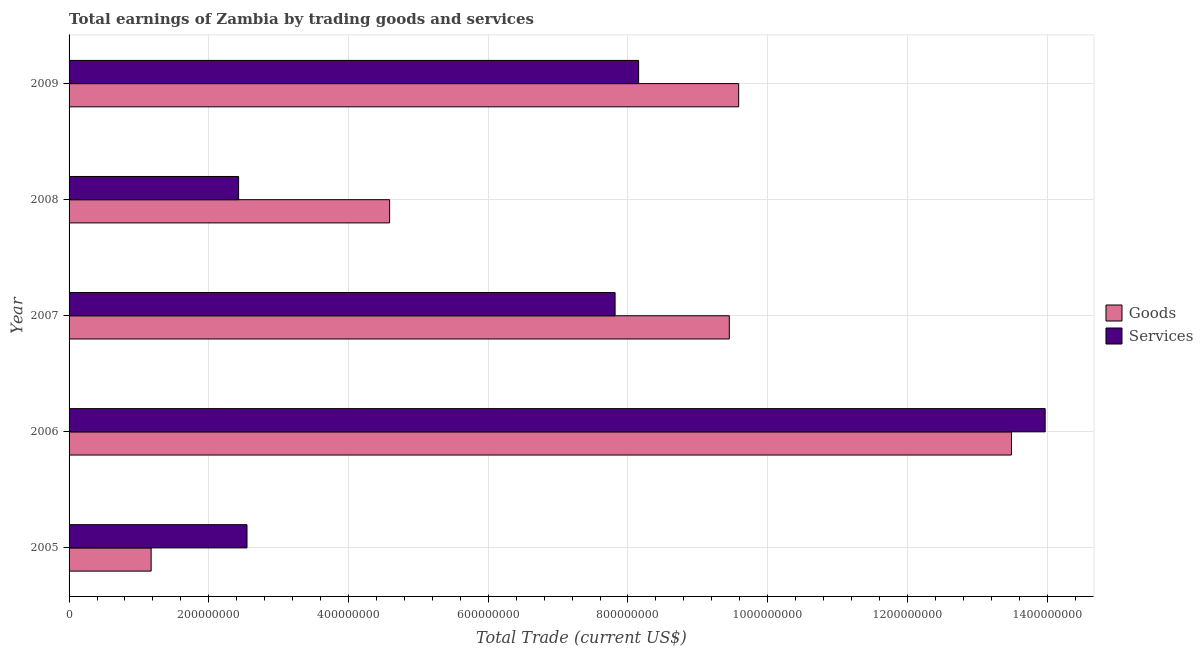How many groups of bars are there?
Your response must be concise. 5. How many bars are there on the 2nd tick from the top?
Offer a terse response. 2. How many bars are there on the 3rd tick from the bottom?
Your response must be concise. 2. What is the label of the 3rd group of bars from the top?
Keep it short and to the point. 2007. What is the amount earned by trading services in 2007?
Offer a very short reply. 7.82e+08. Across all years, what is the maximum amount earned by trading services?
Make the answer very short. 1.40e+09. Across all years, what is the minimum amount earned by trading services?
Ensure brevity in your answer.  2.43e+08. What is the total amount earned by trading services in the graph?
Keep it short and to the point. 3.49e+09. What is the difference between the amount earned by trading goods in 2007 and that in 2009?
Give a very brief answer. -1.34e+07. What is the difference between the amount earned by trading goods in 2009 and the amount earned by trading services in 2008?
Offer a very short reply. 7.16e+08. What is the average amount earned by trading services per year?
Your answer should be compact. 6.98e+08. In the year 2009, what is the difference between the amount earned by trading services and amount earned by trading goods?
Keep it short and to the point. -1.43e+08. In how many years, is the amount earned by trading goods greater than 1040000000 US$?
Ensure brevity in your answer.  1. What is the ratio of the amount earned by trading goods in 2005 to that in 2008?
Your answer should be compact. 0.26. Is the difference between the amount earned by trading services in 2006 and 2007 greater than the difference between the amount earned by trading goods in 2006 and 2007?
Make the answer very short. Yes. What is the difference between the highest and the second highest amount earned by trading services?
Your answer should be very brief. 5.82e+08. What is the difference between the highest and the lowest amount earned by trading services?
Keep it short and to the point. 1.15e+09. Is the sum of the amount earned by trading services in 2005 and 2007 greater than the maximum amount earned by trading goods across all years?
Your response must be concise. No. What does the 1st bar from the top in 2005 represents?
Keep it short and to the point. Services. What does the 1st bar from the bottom in 2009 represents?
Offer a very short reply. Goods. How many bars are there?
Keep it short and to the point. 10. Are all the bars in the graph horizontal?
Ensure brevity in your answer.  Yes. Are the values on the major ticks of X-axis written in scientific E-notation?
Offer a terse response. No. How many legend labels are there?
Ensure brevity in your answer.  2. How are the legend labels stacked?
Make the answer very short. Vertical. What is the title of the graph?
Ensure brevity in your answer.  Total earnings of Zambia by trading goods and services. Does "By country of asylum" appear as one of the legend labels in the graph?
Your response must be concise. No. What is the label or title of the X-axis?
Give a very brief answer. Total Trade (current US$). What is the Total Trade (current US$) in Goods in 2005?
Give a very brief answer. 1.17e+08. What is the Total Trade (current US$) in Services in 2005?
Your answer should be compact. 2.55e+08. What is the Total Trade (current US$) in Goods in 2006?
Offer a very short reply. 1.35e+09. What is the Total Trade (current US$) of Services in 2006?
Your response must be concise. 1.40e+09. What is the Total Trade (current US$) in Goods in 2007?
Your answer should be very brief. 9.45e+08. What is the Total Trade (current US$) in Services in 2007?
Your response must be concise. 7.82e+08. What is the Total Trade (current US$) of Goods in 2008?
Give a very brief answer. 4.59e+08. What is the Total Trade (current US$) of Services in 2008?
Your response must be concise. 2.43e+08. What is the Total Trade (current US$) in Goods in 2009?
Offer a very short reply. 9.59e+08. What is the Total Trade (current US$) of Services in 2009?
Ensure brevity in your answer.  8.15e+08. Across all years, what is the maximum Total Trade (current US$) of Goods?
Provide a succinct answer. 1.35e+09. Across all years, what is the maximum Total Trade (current US$) of Services?
Make the answer very short. 1.40e+09. Across all years, what is the minimum Total Trade (current US$) in Goods?
Keep it short and to the point. 1.17e+08. Across all years, what is the minimum Total Trade (current US$) in Services?
Offer a terse response. 2.43e+08. What is the total Total Trade (current US$) in Goods in the graph?
Your answer should be compact. 3.83e+09. What is the total Total Trade (current US$) of Services in the graph?
Your answer should be very brief. 3.49e+09. What is the difference between the Total Trade (current US$) of Goods in 2005 and that in 2006?
Give a very brief answer. -1.23e+09. What is the difference between the Total Trade (current US$) of Services in 2005 and that in 2006?
Offer a very short reply. -1.14e+09. What is the difference between the Total Trade (current US$) in Goods in 2005 and that in 2007?
Keep it short and to the point. -8.28e+08. What is the difference between the Total Trade (current US$) in Services in 2005 and that in 2007?
Offer a terse response. -5.27e+08. What is the difference between the Total Trade (current US$) in Goods in 2005 and that in 2008?
Provide a succinct answer. -3.41e+08. What is the difference between the Total Trade (current US$) of Services in 2005 and that in 2008?
Keep it short and to the point. 1.20e+07. What is the difference between the Total Trade (current US$) in Goods in 2005 and that in 2009?
Provide a succinct answer. -8.41e+08. What is the difference between the Total Trade (current US$) in Services in 2005 and that in 2009?
Your answer should be compact. -5.61e+08. What is the difference between the Total Trade (current US$) in Goods in 2006 and that in 2007?
Make the answer very short. 4.04e+08. What is the difference between the Total Trade (current US$) of Services in 2006 and that in 2007?
Provide a succinct answer. 6.16e+08. What is the difference between the Total Trade (current US$) in Goods in 2006 and that in 2008?
Ensure brevity in your answer.  8.90e+08. What is the difference between the Total Trade (current US$) of Services in 2006 and that in 2008?
Your answer should be very brief. 1.15e+09. What is the difference between the Total Trade (current US$) of Goods in 2006 and that in 2009?
Keep it short and to the point. 3.90e+08. What is the difference between the Total Trade (current US$) in Services in 2006 and that in 2009?
Ensure brevity in your answer.  5.82e+08. What is the difference between the Total Trade (current US$) of Goods in 2007 and that in 2008?
Provide a short and direct response. 4.86e+08. What is the difference between the Total Trade (current US$) of Services in 2007 and that in 2008?
Provide a short and direct response. 5.39e+08. What is the difference between the Total Trade (current US$) of Goods in 2007 and that in 2009?
Your response must be concise. -1.34e+07. What is the difference between the Total Trade (current US$) of Services in 2007 and that in 2009?
Your answer should be very brief. -3.37e+07. What is the difference between the Total Trade (current US$) in Goods in 2008 and that in 2009?
Ensure brevity in your answer.  -5.00e+08. What is the difference between the Total Trade (current US$) in Services in 2008 and that in 2009?
Keep it short and to the point. -5.73e+08. What is the difference between the Total Trade (current US$) in Goods in 2005 and the Total Trade (current US$) in Services in 2006?
Provide a succinct answer. -1.28e+09. What is the difference between the Total Trade (current US$) of Goods in 2005 and the Total Trade (current US$) of Services in 2007?
Keep it short and to the point. -6.64e+08. What is the difference between the Total Trade (current US$) in Goods in 2005 and the Total Trade (current US$) in Services in 2008?
Offer a very short reply. -1.25e+08. What is the difference between the Total Trade (current US$) in Goods in 2005 and the Total Trade (current US$) in Services in 2009?
Give a very brief answer. -6.98e+08. What is the difference between the Total Trade (current US$) of Goods in 2006 and the Total Trade (current US$) of Services in 2007?
Your answer should be very brief. 5.67e+08. What is the difference between the Total Trade (current US$) of Goods in 2006 and the Total Trade (current US$) of Services in 2008?
Ensure brevity in your answer.  1.11e+09. What is the difference between the Total Trade (current US$) of Goods in 2006 and the Total Trade (current US$) of Services in 2009?
Ensure brevity in your answer.  5.34e+08. What is the difference between the Total Trade (current US$) of Goods in 2007 and the Total Trade (current US$) of Services in 2008?
Make the answer very short. 7.02e+08. What is the difference between the Total Trade (current US$) of Goods in 2007 and the Total Trade (current US$) of Services in 2009?
Offer a very short reply. 1.30e+08. What is the difference between the Total Trade (current US$) in Goods in 2008 and the Total Trade (current US$) in Services in 2009?
Offer a terse response. -3.56e+08. What is the average Total Trade (current US$) of Goods per year?
Keep it short and to the point. 7.66e+08. What is the average Total Trade (current US$) in Services per year?
Provide a short and direct response. 6.98e+08. In the year 2005, what is the difference between the Total Trade (current US$) of Goods and Total Trade (current US$) of Services?
Provide a short and direct response. -1.37e+08. In the year 2006, what is the difference between the Total Trade (current US$) in Goods and Total Trade (current US$) in Services?
Keep it short and to the point. -4.82e+07. In the year 2007, what is the difference between the Total Trade (current US$) of Goods and Total Trade (current US$) of Services?
Your answer should be compact. 1.63e+08. In the year 2008, what is the difference between the Total Trade (current US$) in Goods and Total Trade (current US$) in Services?
Your answer should be very brief. 2.16e+08. In the year 2009, what is the difference between the Total Trade (current US$) in Goods and Total Trade (current US$) in Services?
Your answer should be very brief. 1.43e+08. What is the ratio of the Total Trade (current US$) in Goods in 2005 to that in 2006?
Your response must be concise. 0.09. What is the ratio of the Total Trade (current US$) in Services in 2005 to that in 2006?
Keep it short and to the point. 0.18. What is the ratio of the Total Trade (current US$) in Goods in 2005 to that in 2007?
Keep it short and to the point. 0.12. What is the ratio of the Total Trade (current US$) of Services in 2005 to that in 2007?
Your answer should be very brief. 0.33. What is the ratio of the Total Trade (current US$) of Goods in 2005 to that in 2008?
Your answer should be very brief. 0.26. What is the ratio of the Total Trade (current US$) in Services in 2005 to that in 2008?
Give a very brief answer. 1.05. What is the ratio of the Total Trade (current US$) of Goods in 2005 to that in 2009?
Keep it short and to the point. 0.12. What is the ratio of the Total Trade (current US$) in Services in 2005 to that in 2009?
Provide a succinct answer. 0.31. What is the ratio of the Total Trade (current US$) of Goods in 2006 to that in 2007?
Your answer should be very brief. 1.43. What is the ratio of the Total Trade (current US$) of Services in 2006 to that in 2007?
Your answer should be very brief. 1.79. What is the ratio of the Total Trade (current US$) of Goods in 2006 to that in 2008?
Give a very brief answer. 2.94. What is the ratio of the Total Trade (current US$) of Services in 2006 to that in 2008?
Provide a succinct answer. 5.76. What is the ratio of the Total Trade (current US$) in Goods in 2006 to that in 2009?
Provide a succinct answer. 1.41. What is the ratio of the Total Trade (current US$) in Services in 2006 to that in 2009?
Offer a terse response. 1.71. What is the ratio of the Total Trade (current US$) of Goods in 2007 to that in 2008?
Ensure brevity in your answer.  2.06. What is the ratio of the Total Trade (current US$) in Services in 2007 to that in 2008?
Offer a very short reply. 3.22. What is the ratio of the Total Trade (current US$) of Services in 2007 to that in 2009?
Give a very brief answer. 0.96. What is the ratio of the Total Trade (current US$) in Goods in 2008 to that in 2009?
Your response must be concise. 0.48. What is the ratio of the Total Trade (current US$) in Services in 2008 to that in 2009?
Provide a short and direct response. 0.3. What is the difference between the highest and the second highest Total Trade (current US$) in Goods?
Give a very brief answer. 3.90e+08. What is the difference between the highest and the second highest Total Trade (current US$) of Services?
Provide a short and direct response. 5.82e+08. What is the difference between the highest and the lowest Total Trade (current US$) in Goods?
Offer a very short reply. 1.23e+09. What is the difference between the highest and the lowest Total Trade (current US$) of Services?
Provide a short and direct response. 1.15e+09. 